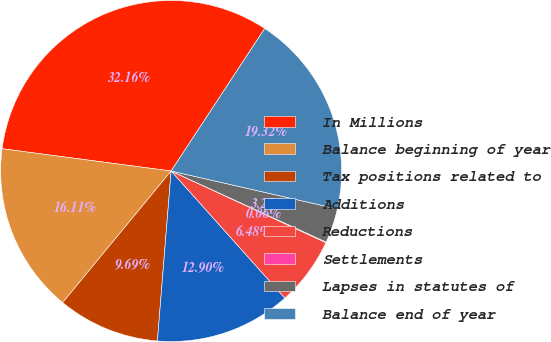Convert chart to OTSL. <chart><loc_0><loc_0><loc_500><loc_500><pie_chart><fcel>In Millions<fcel>Balance beginning of year<fcel>Tax positions related to<fcel>Additions<fcel>Reductions<fcel>Settlements<fcel>Lapses in statutes of<fcel>Balance end of year<nl><fcel>32.16%<fcel>16.11%<fcel>9.69%<fcel>12.9%<fcel>6.48%<fcel>0.06%<fcel>3.27%<fcel>19.32%<nl></chart> 